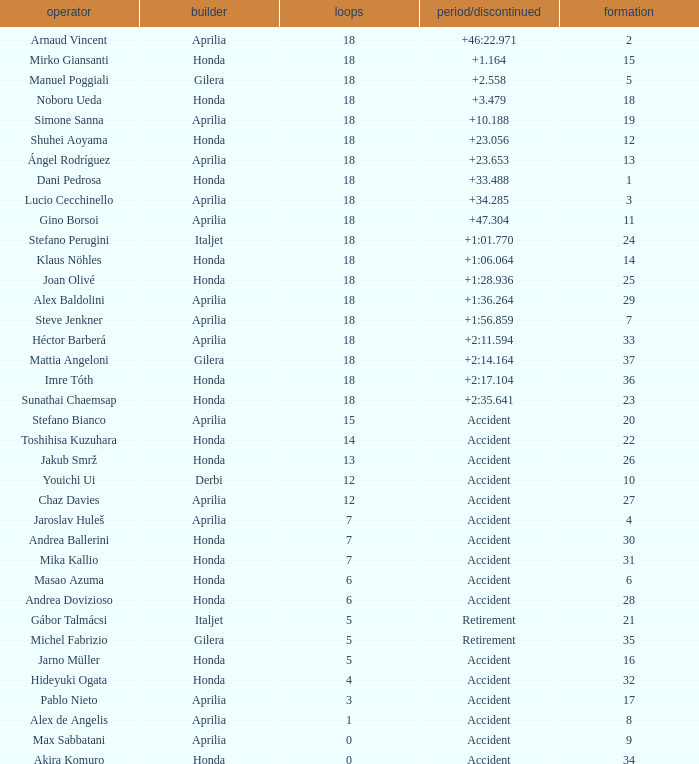Who is the rider with less than 15 laps, more than 32 grids, and an accident time/retired? Akira Komuro. 